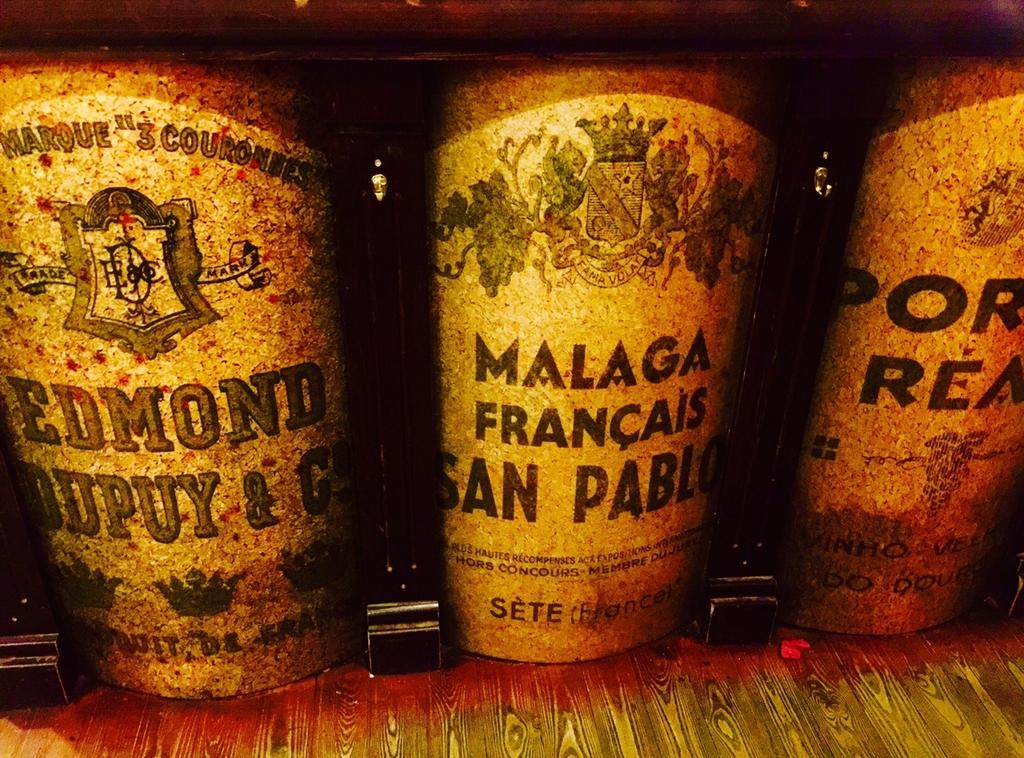What country is listed on the middle bottle?
Your response must be concise. France. 